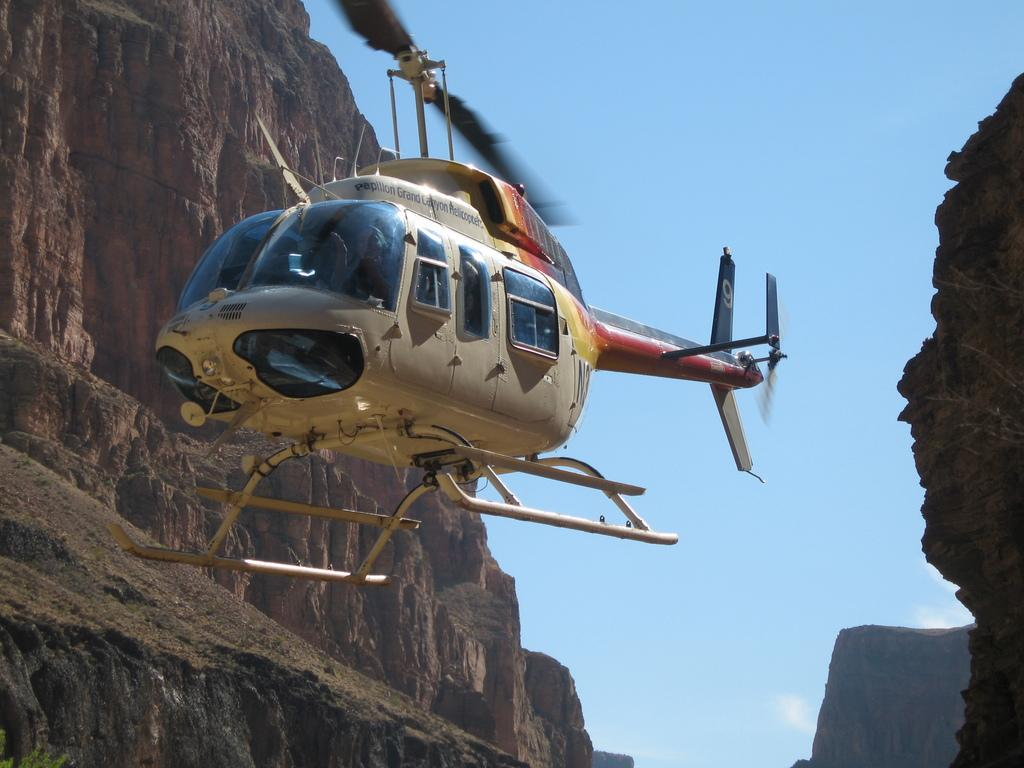What is the main subject in the center of the image? There is a helicopter in the air in the center of the image. What can be seen on both sides of the helicopter? There are rocks on both the right and left sides of the image. What is visible in the background of the image? The sky is visible in the background of the image. What record is being played on the helicopter's radio in the image? There is no mention of a radio or any records in the image; it only features a helicopter in the air and rocks on both sides. 